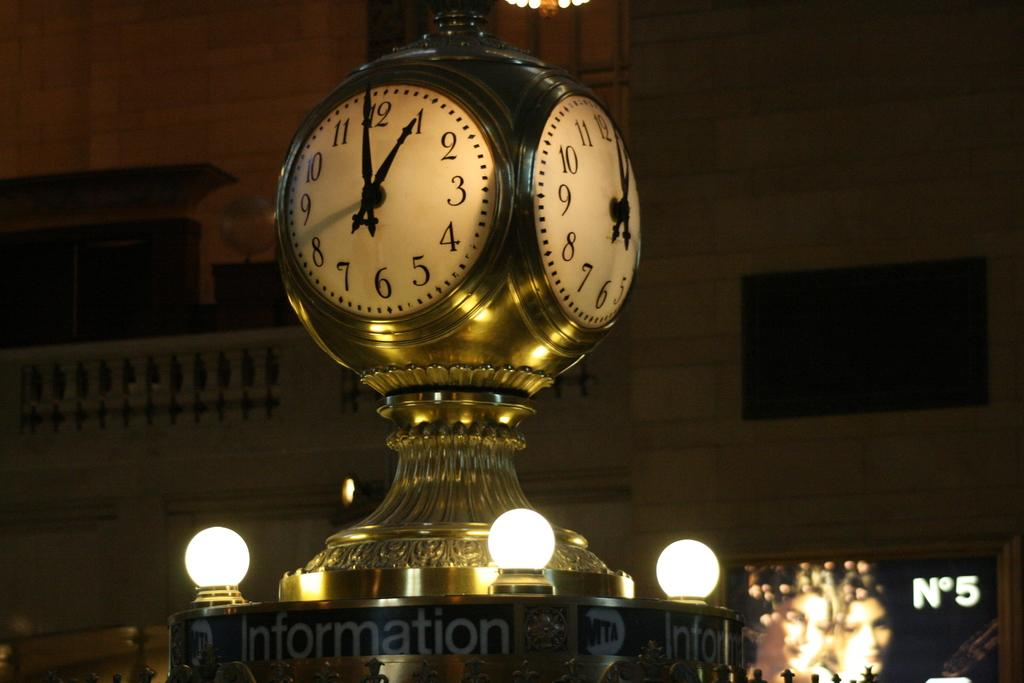<image>
Relay a brief, clear account of the picture shown. A clock is sitting on a stand and the word information is on the stand. 